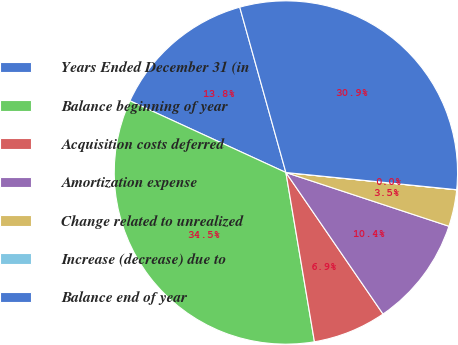Convert chart to OTSL. <chart><loc_0><loc_0><loc_500><loc_500><pie_chart><fcel>Years Ended December 31 (in<fcel>Balance beginning of year<fcel>Acquisition costs deferred<fcel>Amortization expense<fcel>Change related to unrealized<fcel>Increase (decrease) due to<fcel>Balance end of year<nl><fcel>13.81%<fcel>34.51%<fcel>6.91%<fcel>10.36%<fcel>3.46%<fcel>0.01%<fcel>30.92%<nl></chart> 